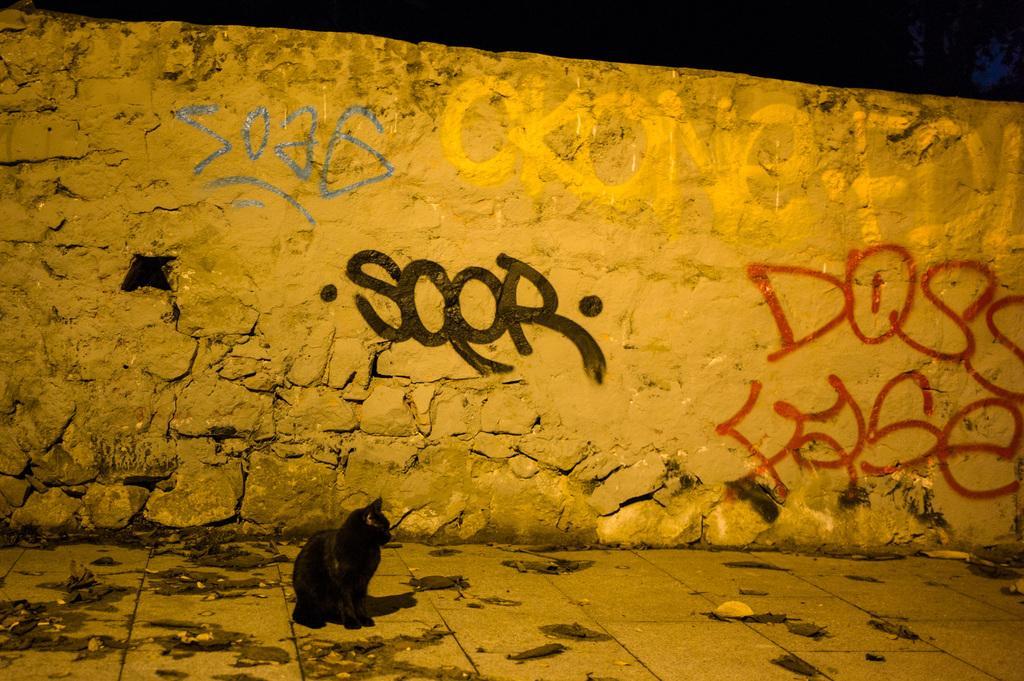Could you give a brief overview of what you see in this image? In this picture we can observe a black color cat on the floor. In the background there is a stone wall on which we can observe blue, black and red color words written on it. In the background it is completely dark. 